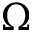Convert formula to latex. <formula><loc_0><loc_0><loc_500><loc_500>\Omega</formula> 